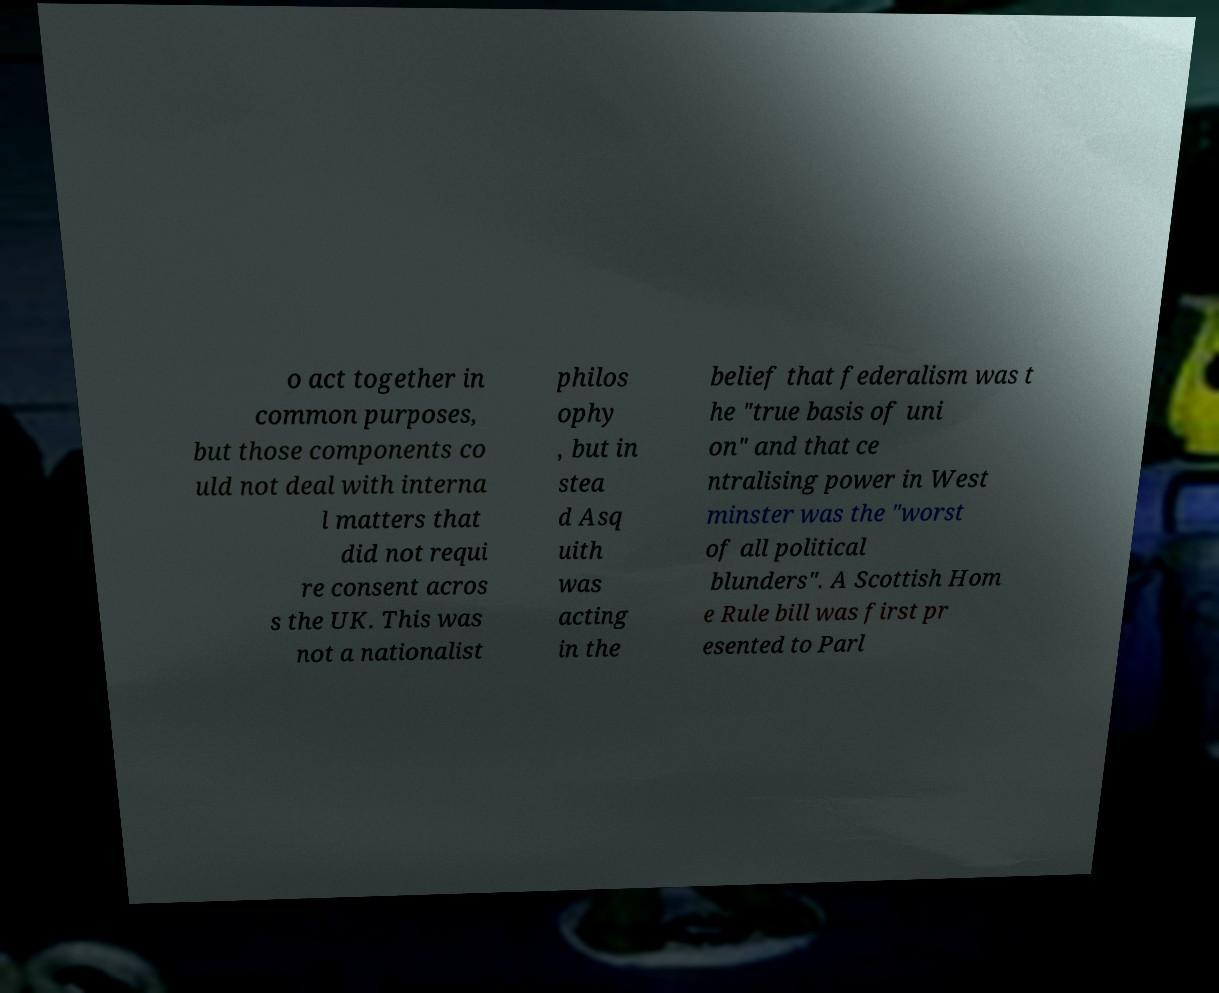For documentation purposes, I need the text within this image transcribed. Could you provide that? o act together in common purposes, but those components co uld not deal with interna l matters that did not requi re consent acros s the UK. This was not a nationalist philos ophy , but in stea d Asq uith was acting in the belief that federalism was t he "true basis of uni on" and that ce ntralising power in West minster was the "worst of all political blunders". A Scottish Hom e Rule bill was first pr esented to Parl 